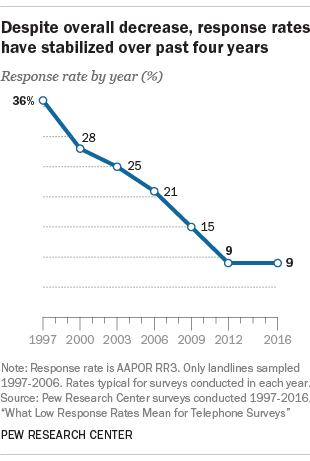Mention a couple of crucial points in this snapshot. The mode of the data points is 9. It is clear from the data that the response rates stabilized in 2012, ending a period of fluctuation that had occurred prior to that year. 